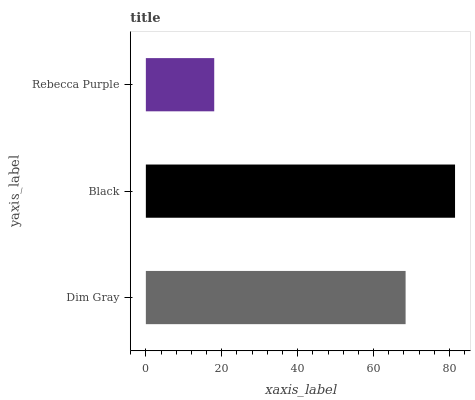Is Rebecca Purple the minimum?
Answer yes or no. Yes. Is Black the maximum?
Answer yes or no. Yes. Is Black the minimum?
Answer yes or no. No. Is Rebecca Purple the maximum?
Answer yes or no. No. Is Black greater than Rebecca Purple?
Answer yes or no. Yes. Is Rebecca Purple less than Black?
Answer yes or no. Yes. Is Rebecca Purple greater than Black?
Answer yes or no. No. Is Black less than Rebecca Purple?
Answer yes or no. No. Is Dim Gray the high median?
Answer yes or no. Yes. Is Dim Gray the low median?
Answer yes or no. Yes. Is Rebecca Purple the high median?
Answer yes or no. No. Is Rebecca Purple the low median?
Answer yes or no. No. 